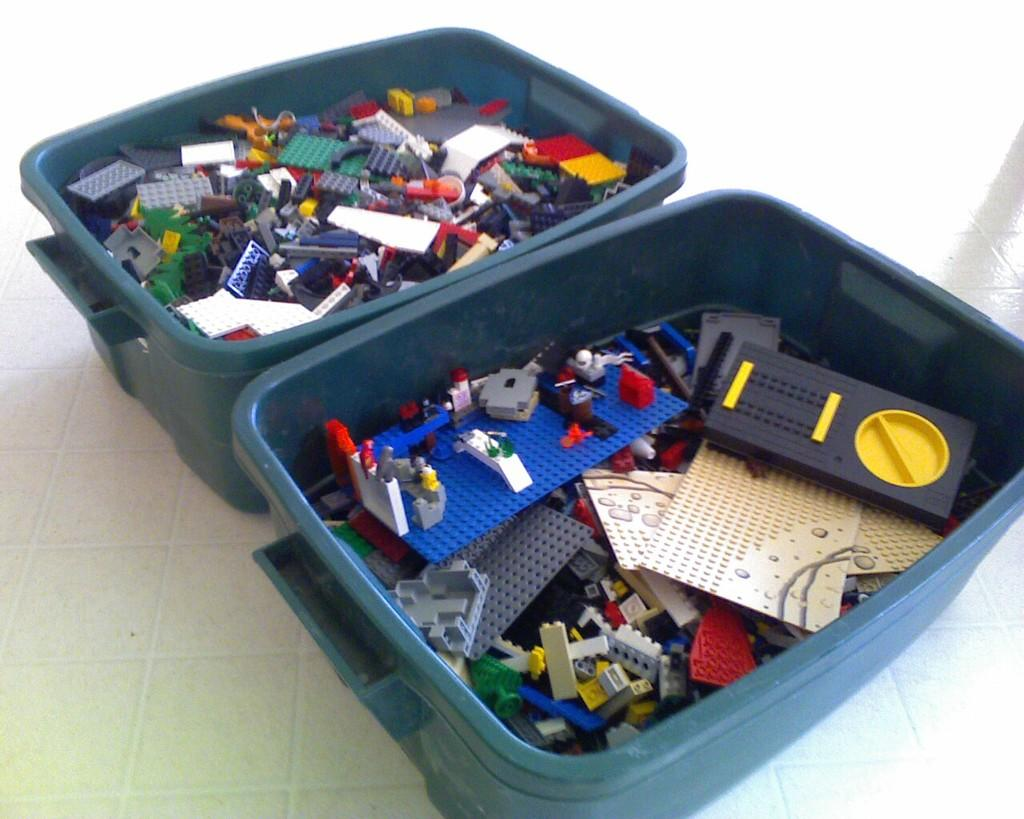What is located in the center of the image? There are containers in the center of the image. What are the containers holding? The containers hold Lego pieces. Where are the containers placed? The containers are placed on the ground. What type of ear is visible on the Lego pieces in the image? There are no ears visible on the Lego pieces in the image, as Lego pieces do not have ears. 